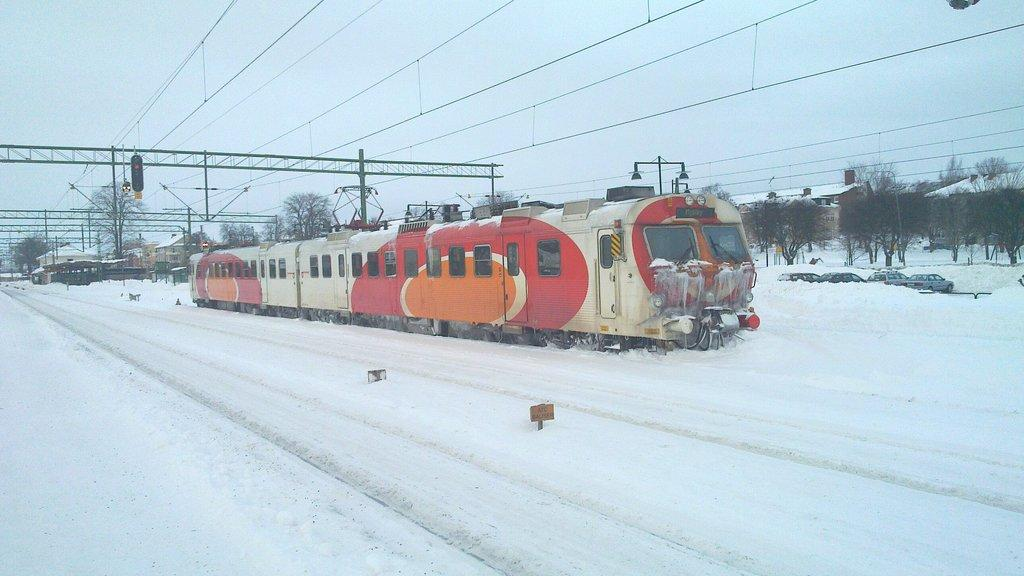What is the main subject of the image? There is a train in the image. What is the condition of the road in the image? Snow is present on the road. Can you describe the objects visible in the image? There are objects visible in the image, but their specific nature is not mentioned in the facts. What can be seen in the background of the image? There are trees, houses, electric poles, wires, and the sky visible in the background of the image. What type of furniture can be seen in the image? There is no furniture present in the image; it features a train and various background elements. How many fingers are visible on the train in the image? There are no fingers visible in the image, as it features a train and various background elements. 